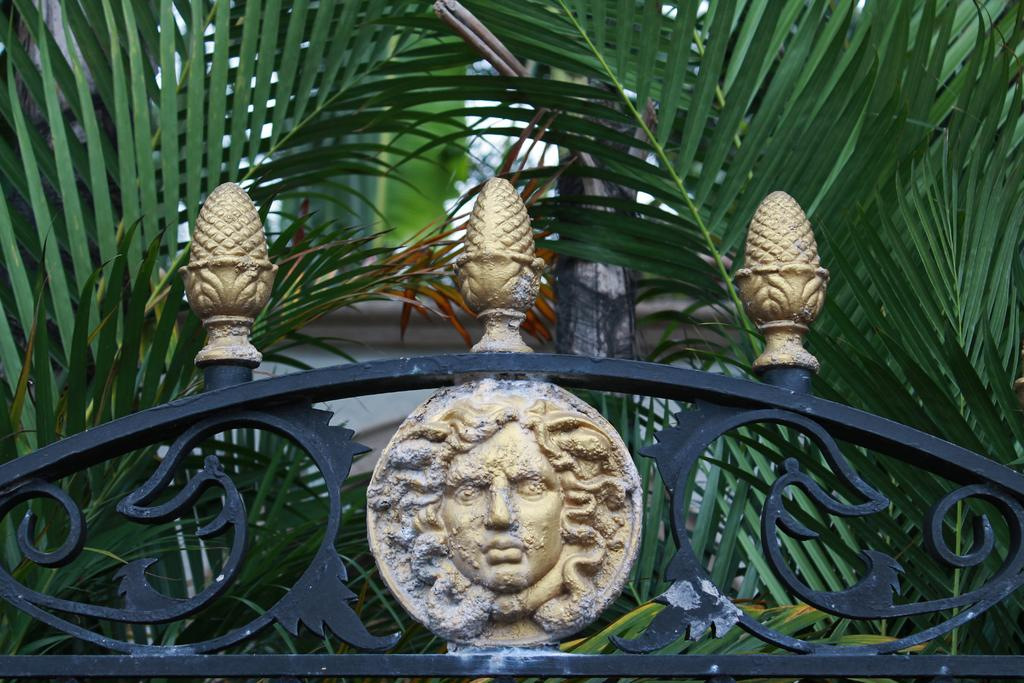What is the main object in the image? There is a grill with a design in the image. What is placed on the grill? There is a sculpture on the grill. What can be seen in the background of the image? There are palm leaves in the background of the image. What type of insurance policy is being advertised on the grill? There is no insurance policy or advertisement present in the image; it features a grill with a sculpture and palm leaves in the background. 